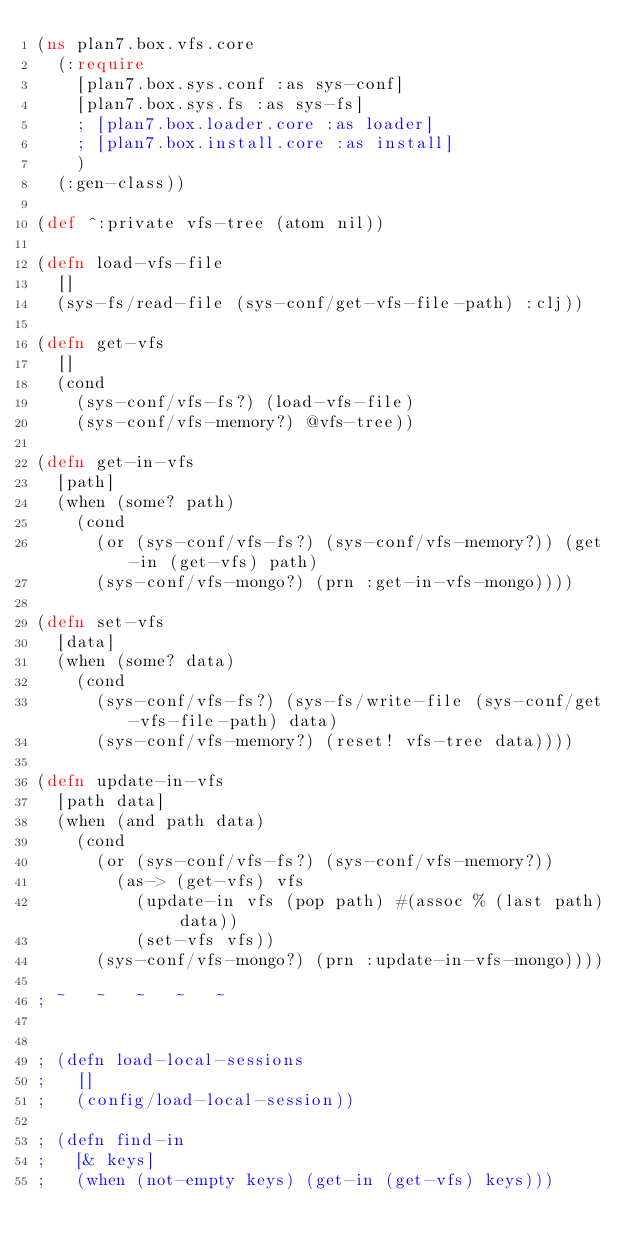Convert code to text. <code><loc_0><loc_0><loc_500><loc_500><_Clojure_>(ns plan7.box.vfs.core
  (:require
    [plan7.box.sys.conf :as sys-conf]
    [plan7.box.sys.fs :as sys-fs]
    ; [plan7.box.loader.core :as loader]
    ; [plan7.box.install.core :as install]
    )
  (:gen-class))

(def ^:private vfs-tree (atom nil))

(defn load-vfs-file
  []
  (sys-fs/read-file (sys-conf/get-vfs-file-path) :clj))

(defn get-vfs
  []
  (cond
    (sys-conf/vfs-fs?) (load-vfs-file)
    (sys-conf/vfs-memory?) @vfs-tree))

(defn get-in-vfs
  [path]
  (when (some? path)
    (cond
      (or (sys-conf/vfs-fs?) (sys-conf/vfs-memory?)) (get-in (get-vfs) path)
      (sys-conf/vfs-mongo?) (prn :get-in-vfs-mongo))))

(defn set-vfs
  [data]
  (when (some? data)
    (cond
      (sys-conf/vfs-fs?) (sys-fs/write-file (sys-conf/get-vfs-file-path) data)
      (sys-conf/vfs-memory?) (reset! vfs-tree data))))

(defn update-in-vfs
  [path data]
  (when (and path data)
    (cond
      (or (sys-conf/vfs-fs?) (sys-conf/vfs-memory?))
        (as-> (get-vfs) vfs
          (update-in vfs (pop path) #(assoc % (last path) data))
          (set-vfs vfs))
      (sys-conf/vfs-mongo?) (prn :update-in-vfs-mongo))))

; ~   ~   ~   ~   ~


; (defn load-local-sessions
;   []
;   (config/load-local-session))

; (defn find-in
;   [& keys]
;   (when (not-empty keys) (get-in (get-vfs) keys)))</code> 